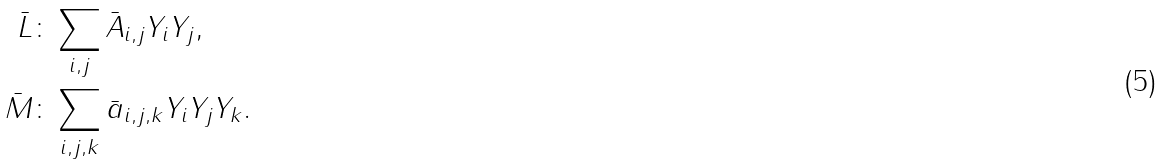<formula> <loc_0><loc_0><loc_500><loc_500>\bar { L } & \colon \sum _ { i , j } \bar { A } _ { i , j } Y _ { i } Y _ { j } , \\ \bar { M } & \colon \sum _ { i , j , k } \bar { a } _ { i , j , k } Y _ { i } Y _ { j } Y _ { k } .</formula> 